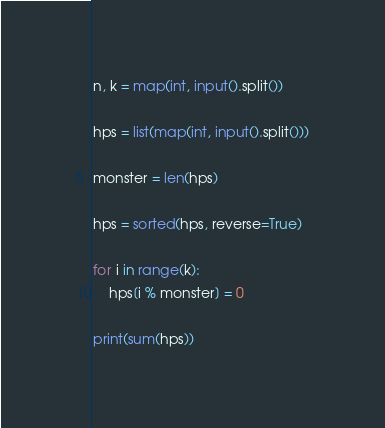<code> <loc_0><loc_0><loc_500><loc_500><_Python_>n, k = map(int, input().split())

hps = list(map(int, input().split()))

monster = len(hps)

hps = sorted(hps, reverse=True)

for i in range(k):
    hps[i % monster] = 0

print(sum(hps))</code> 